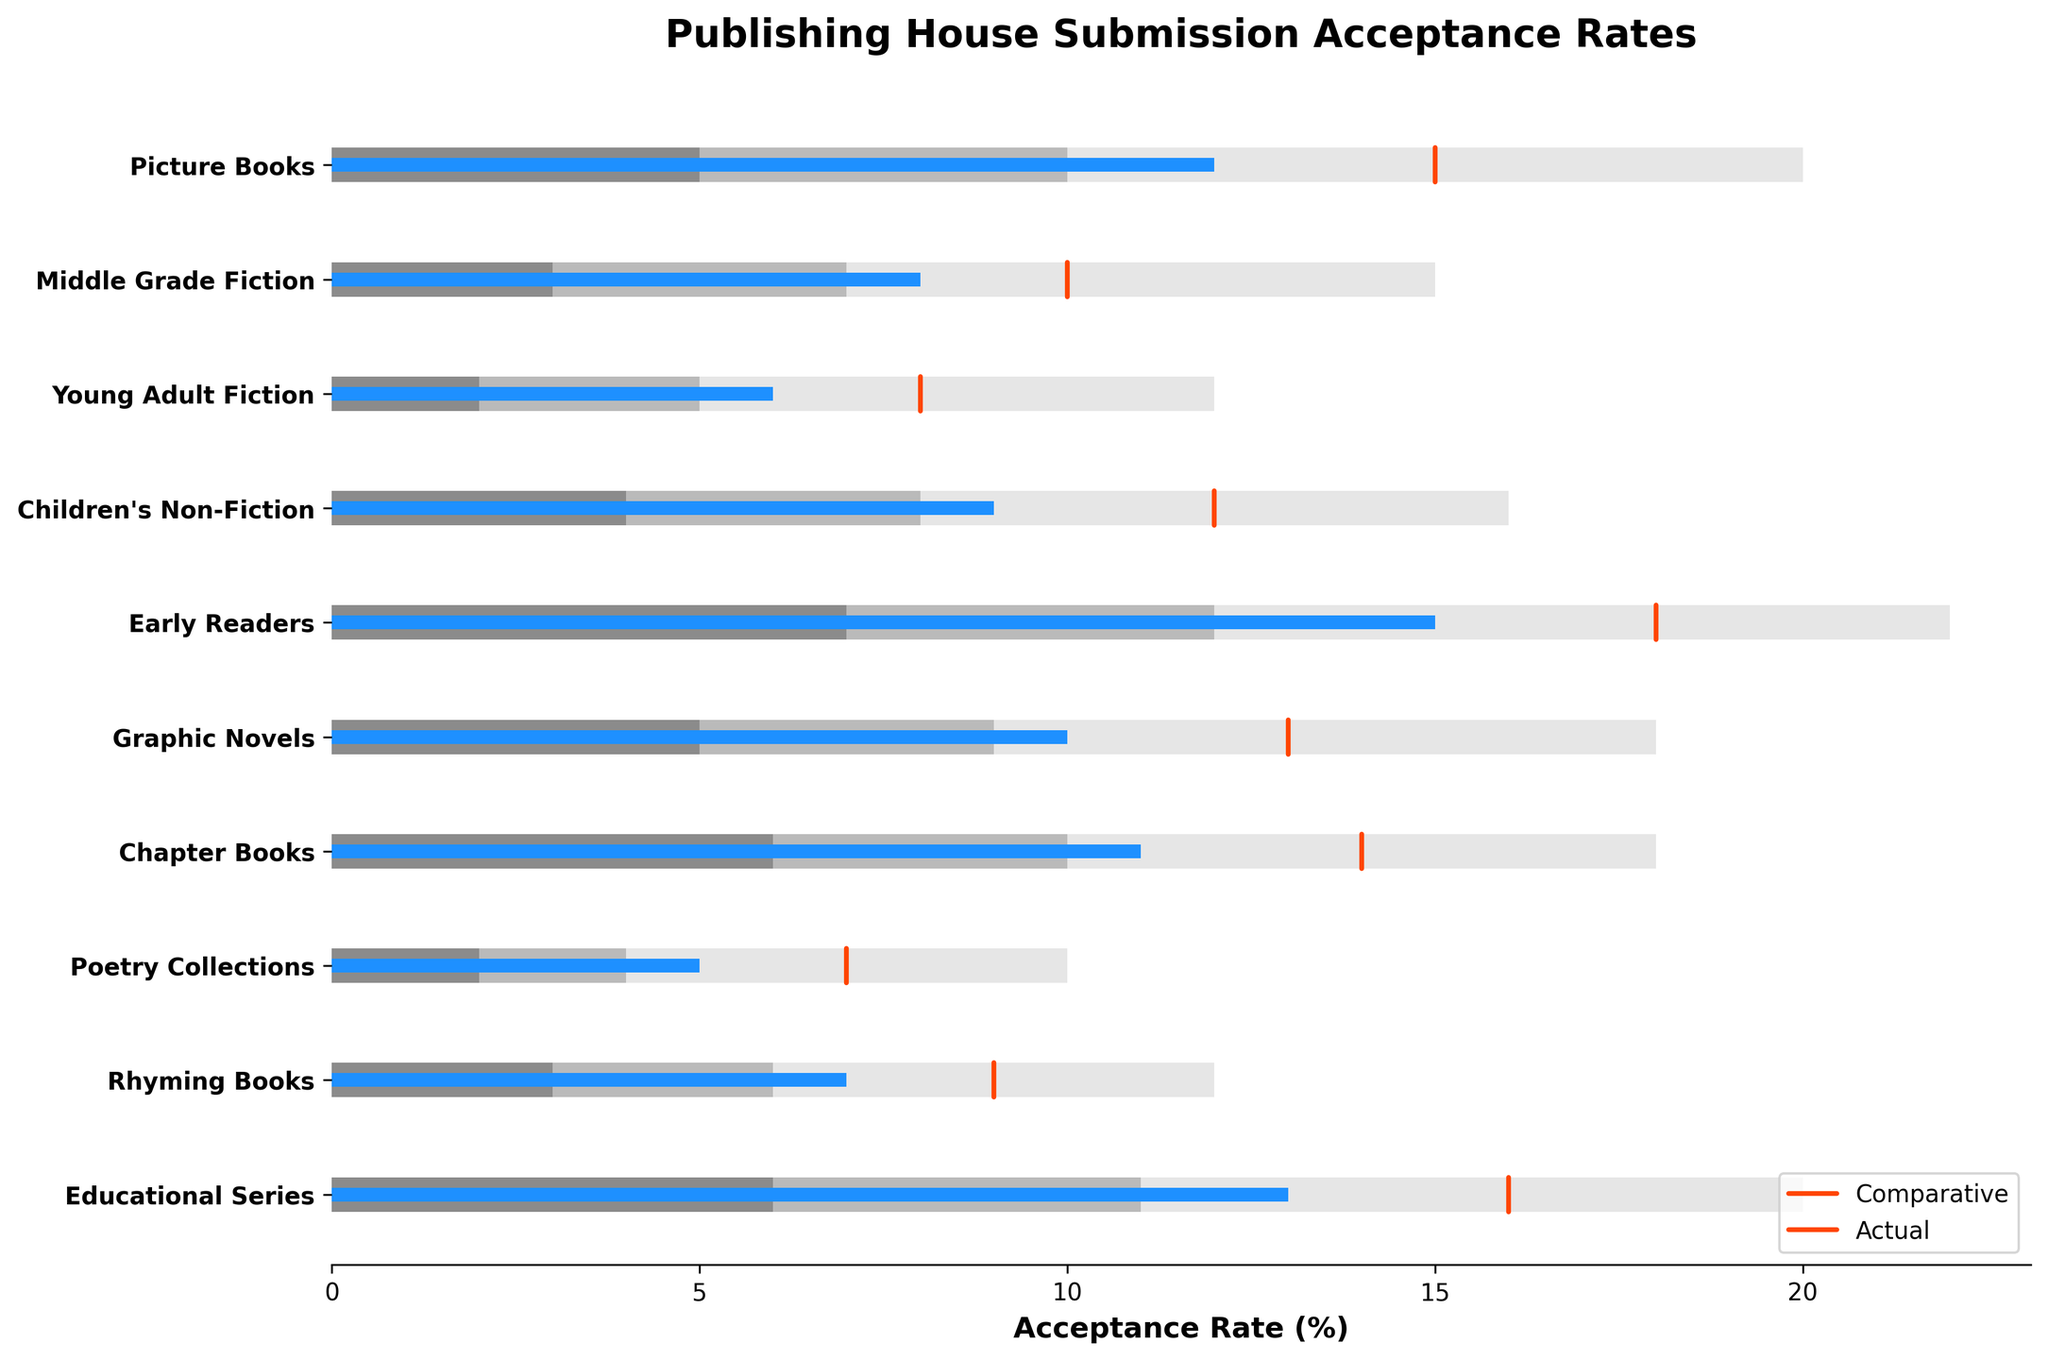How many book types are displayed in the chart? The chart shows categories, each representing a different book type. To count book types, count the categories listed.
Answer: 10 What is the title of the chart? The title is typically located at the top of the chart. Here it specifies the context of the data shown.
Answer: Publishing House Submission Acceptance Rates Which book type has the highest actual acceptance rate? Examine the actual values represented by the blue bars. Identify which bar is the longest.
Answer: Early Readers What is the lowest comparative acceptance rate, and which book type does it belong to? Examine the red dashed lines that indicate comparative values. Identify the smallest value.
Answer: Poetry Collections, 7 How does the actual acceptance rate for Graphic Novels compare to the middle of the expected range for this category? Identify Graphic Novels' actual rate (10) and compare it with the middle range value (9) for the category Graphic Novels.
Answer: It is higher What is the difference between the actual and comparative acceptance rates for Rhyming Books? Subtract the actual rate (7) from the comparative rate (9) for Rhyming Books.
Answer: 2 Compare the highest range value for Middle Grade Fiction to the actual acceptance rate for Educational Series. Which is higher? Compare the highest range value for Middle Grade Fiction (15) to the actual value for Educational Series (13).
Answer: Middle Grade Fiction's highest range value (15) is higher What is the average actual acceptance rate for Picture Books and Early Readers? Add the actual rates for Picture Books (12) and Early Readers (15), then divide by 2.
Answer: 13.5 For which book types is the actual acceptance rate within the expected range? For each book type, ensure the actual rate is between the lowest and highest range values.
Answer: Picture Books, Middle Grade Fiction, Young Adult Fiction, Children's Non-Fiction, Graphic Novels, Chapter Books, Educational Series Which book type has the smallest range? Calculate the difference between the highest and lowest range values for each book type and find the smallest difference.
Answer: Poetry Collections 